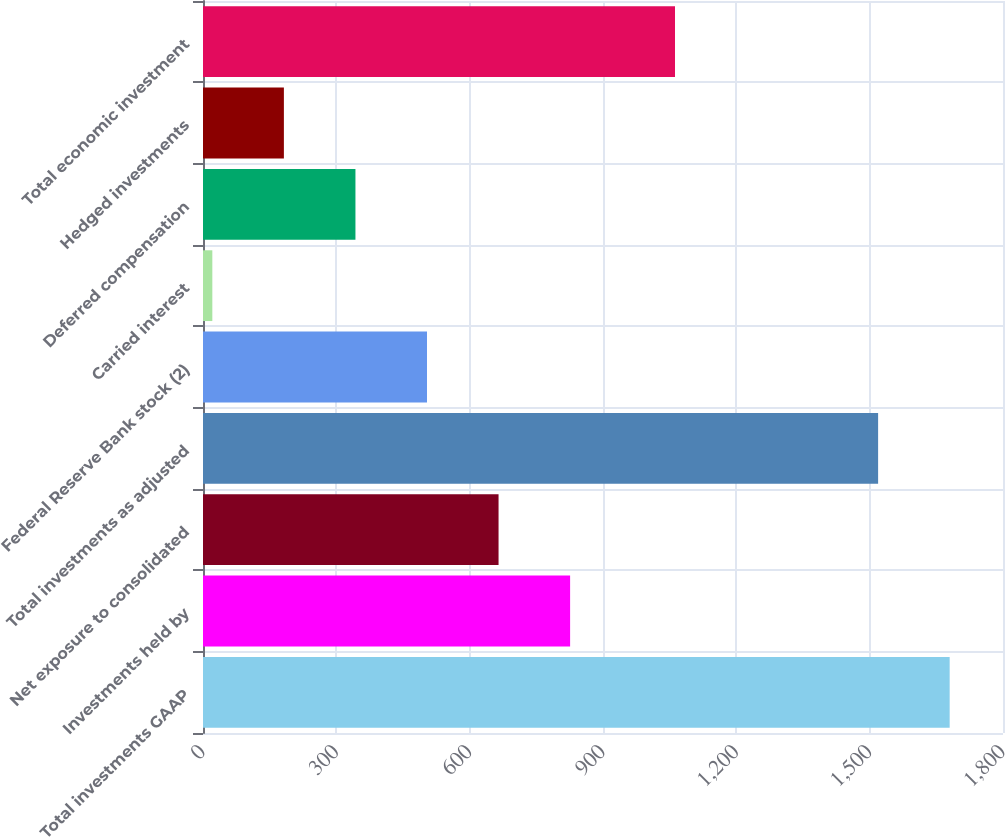Convert chart to OTSL. <chart><loc_0><loc_0><loc_500><loc_500><bar_chart><fcel>Total investments GAAP<fcel>Investments held by<fcel>Net exposure to consolidated<fcel>Total investments as adjusted<fcel>Federal Reserve Bank stock (2)<fcel>Carried interest<fcel>Deferred compensation<fcel>Hedged investments<fcel>Total economic investment<nl><fcel>1680<fcel>826<fcel>665<fcel>1519<fcel>504<fcel>21<fcel>343<fcel>182<fcel>1062<nl></chart> 